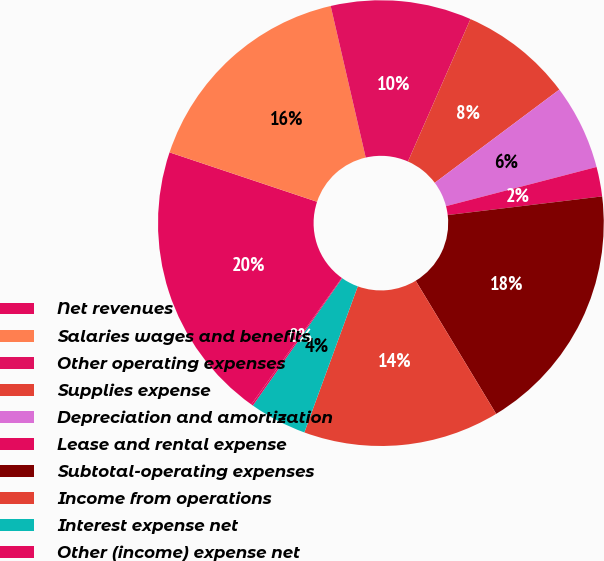<chart> <loc_0><loc_0><loc_500><loc_500><pie_chart><fcel>Net revenues<fcel>Salaries wages and benefits<fcel>Other operating expenses<fcel>Supplies expense<fcel>Depreciation and amortization<fcel>Lease and rental expense<fcel>Subtotal-operating expenses<fcel>Income from operations<fcel>Interest expense net<fcel>Other (income) expense net<nl><fcel>20.27%<fcel>16.24%<fcel>10.2%<fcel>8.19%<fcel>6.17%<fcel>2.14%<fcel>18.26%<fcel>14.23%<fcel>4.16%<fcel>0.13%<nl></chart> 